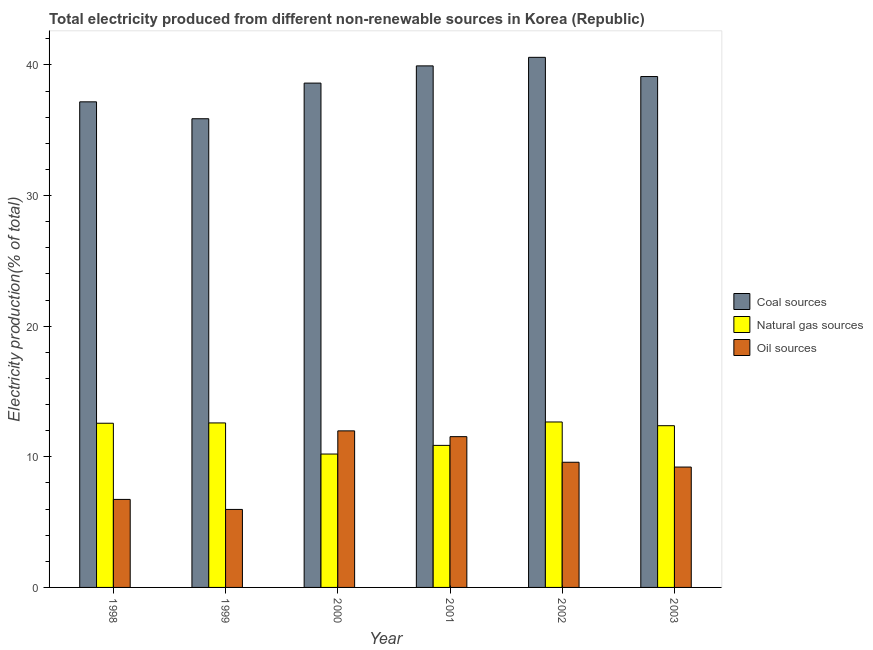How many different coloured bars are there?
Provide a succinct answer. 3. Are the number of bars per tick equal to the number of legend labels?
Provide a short and direct response. Yes. Are the number of bars on each tick of the X-axis equal?
Ensure brevity in your answer.  Yes. How many bars are there on the 2nd tick from the right?
Keep it short and to the point. 3. What is the label of the 5th group of bars from the left?
Your response must be concise. 2002. In how many cases, is the number of bars for a given year not equal to the number of legend labels?
Provide a succinct answer. 0. What is the percentage of electricity produced by coal in 2002?
Ensure brevity in your answer.  40.58. Across all years, what is the maximum percentage of electricity produced by coal?
Your answer should be very brief. 40.58. Across all years, what is the minimum percentage of electricity produced by natural gas?
Provide a succinct answer. 10.21. In which year was the percentage of electricity produced by natural gas minimum?
Give a very brief answer. 2000. What is the total percentage of electricity produced by natural gas in the graph?
Ensure brevity in your answer.  71.29. What is the difference between the percentage of electricity produced by oil sources in 1999 and that in 2003?
Offer a very short reply. -3.24. What is the difference between the percentage of electricity produced by coal in 2000 and the percentage of electricity produced by natural gas in 2002?
Ensure brevity in your answer.  -1.97. What is the average percentage of electricity produced by coal per year?
Your response must be concise. 38.55. In the year 2000, what is the difference between the percentage of electricity produced by coal and percentage of electricity produced by natural gas?
Your response must be concise. 0. In how many years, is the percentage of electricity produced by oil sources greater than 10 %?
Keep it short and to the point. 2. What is the ratio of the percentage of electricity produced by coal in 2000 to that in 2002?
Ensure brevity in your answer.  0.95. What is the difference between the highest and the second highest percentage of electricity produced by natural gas?
Provide a succinct answer. 0.07. What is the difference between the highest and the lowest percentage of electricity produced by coal?
Your answer should be very brief. 4.7. In how many years, is the percentage of electricity produced by coal greater than the average percentage of electricity produced by coal taken over all years?
Your response must be concise. 4. Is the sum of the percentage of electricity produced by coal in 2002 and 2003 greater than the maximum percentage of electricity produced by oil sources across all years?
Keep it short and to the point. Yes. What does the 3rd bar from the left in 1998 represents?
Keep it short and to the point. Oil sources. What does the 1st bar from the right in 2003 represents?
Your answer should be compact. Oil sources. Is it the case that in every year, the sum of the percentage of electricity produced by coal and percentage of electricity produced by natural gas is greater than the percentage of electricity produced by oil sources?
Offer a terse response. Yes. How many bars are there?
Your response must be concise. 18. How many years are there in the graph?
Your response must be concise. 6. What is the difference between two consecutive major ticks on the Y-axis?
Give a very brief answer. 10. Does the graph contain any zero values?
Your answer should be compact. No. Where does the legend appear in the graph?
Your answer should be very brief. Center right. How are the legend labels stacked?
Offer a very short reply. Vertical. What is the title of the graph?
Your response must be concise. Total electricity produced from different non-renewable sources in Korea (Republic). Does "Poland" appear as one of the legend labels in the graph?
Ensure brevity in your answer.  No. What is the label or title of the X-axis?
Give a very brief answer. Year. What is the Electricity production(% of total) in Coal sources in 1998?
Make the answer very short. 37.17. What is the Electricity production(% of total) of Natural gas sources in 1998?
Offer a terse response. 12.57. What is the Electricity production(% of total) of Oil sources in 1998?
Offer a very short reply. 6.74. What is the Electricity production(% of total) in Coal sources in 1999?
Make the answer very short. 35.88. What is the Electricity production(% of total) in Natural gas sources in 1999?
Give a very brief answer. 12.59. What is the Electricity production(% of total) of Oil sources in 1999?
Offer a very short reply. 5.97. What is the Electricity production(% of total) of Coal sources in 2000?
Your answer should be very brief. 38.61. What is the Electricity production(% of total) in Natural gas sources in 2000?
Your answer should be compact. 10.21. What is the Electricity production(% of total) of Oil sources in 2000?
Provide a succinct answer. 11.99. What is the Electricity production(% of total) in Coal sources in 2001?
Your answer should be compact. 39.93. What is the Electricity production(% of total) in Natural gas sources in 2001?
Your response must be concise. 10.87. What is the Electricity production(% of total) of Oil sources in 2001?
Keep it short and to the point. 11.54. What is the Electricity production(% of total) in Coal sources in 2002?
Keep it short and to the point. 40.58. What is the Electricity production(% of total) of Natural gas sources in 2002?
Give a very brief answer. 12.67. What is the Electricity production(% of total) of Oil sources in 2002?
Your answer should be very brief. 9.58. What is the Electricity production(% of total) of Coal sources in 2003?
Make the answer very short. 39.11. What is the Electricity production(% of total) in Natural gas sources in 2003?
Give a very brief answer. 12.38. What is the Electricity production(% of total) of Oil sources in 2003?
Give a very brief answer. 9.21. Across all years, what is the maximum Electricity production(% of total) in Coal sources?
Your answer should be compact. 40.58. Across all years, what is the maximum Electricity production(% of total) of Natural gas sources?
Your answer should be compact. 12.67. Across all years, what is the maximum Electricity production(% of total) in Oil sources?
Offer a terse response. 11.99. Across all years, what is the minimum Electricity production(% of total) in Coal sources?
Offer a terse response. 35.88. Across all years, what is the minimum Electricity production(% of total) of Natural gas sources?
Your response must be concise. 10.21. Across all years, what is the minimum Electricity production(% of total) of Oil sources?
Keep it short and to the point. 5.97. What is the total Electricity production(% of total) of Coal sources in the graph?
Give a very brief answer. 231.28. What is the total Electricity production(% of total) in Natural gas sources in the graph?
Your answer should be compact. 71.29. What is the total Electricity production(% of total) in Oil sources in the graph?
Provide a succinct answer. 55.03. What is the difference between the Electricity production(% of total) of Coal sources in 1998 and that in 1999?
Keep it short and to the point. 1.29. What is the difference between the Electricity production(% of total) of Natural gas sources in 1998 and that in 1999?
Your response must be concise. -0.02. What is the difference between the Electricity production(% of total) in Oil sources in 1998 and that in 1999?
Provide a succinct answer. 0.77. What is the difference between the Electricity production(% of total) of Coal sources in 1998 and that in 2000?
Provide a short and direct response. -1.43. What is the difference between the Electricity production(% of total) in Natural gas sources in 1998 and that in 2000?
Your answer should be compact. 2.36. What is the difference between the Electricity production(% of total) of Oil sources in 1998 and that in 2000?
Offer a very short reply. -5.25. What is the difference between the Electricity production(% of total) in Coal sources in 1998 and that in 2001?
Give a very brief answer. -2.75. What is the difference between the Electricity production(% of total) of Natural gas sources in 1998 and that in 2001?
Ensure brevity in your answer.  1.69. What is the difference between the Electricity production(% of total) of Oil sources in 1998 and that in 2001?
Your answer should be very brief. -4.81. What is the difference between the Electricity production(% of total) of Coal sources in 1998 and that in 2002?
Keep it short and to the point. -3.41. What is the difference between the Electricity production(% of total) of Natural gas sources in 1998 and that in 2002?
Ensure brevity in your answer.  -0.1. What is the difference between the Electricity production(% of total) of Oil sources in 1998 and that in 2002?
Keep it short and to the point. -2.85. What is the difference between the Electricity production(% of total) of Coal sources in 1998 and that in 2003?
Ensure brevity in your answer.  -1.94. What is the difference between the Electricity production(% of total) in Natural gas sources in 1998 and that in 2003?
Provide a short and direct response. 0.19. What is the difference between the Electricity production(% of total) in Oil sources in 1998 and that in 2003?
Your response must be concise. -2.48. What is the difference between the Electricity production(% of total) in Coal sources in 1999 and that in 2000?
Keep it short and to the point. -2.73. What is the difference between the Electricity production(% of total) of Natural gas sources in 1999 and that in 2000?
Your answer should be compact. 2.38. What is the difference between the Electricity production(% of total) of Oil sources in 1999 and that in 2000?
Provide a short and direct response. -6.01. What is the difference between the Electricity production(% of total) in Coal sources in 1999 and that in 2001?
Your answer should be very brief. -4.05. What is the difference between the Electricity production(% of total) of Natural gas sources in 1999 and that in 2001?
Keep it short and to the point. 1.72. What is the difference between the Electricity production(% of total) in Oil sources in 1999 and that in 2001?
Provide a short and direct response. -5.57. What is the difference between the Electricity production(% of total) in Coal sources in 1999 and that in 2002?
Give a very brief answer. -4.7. What is the difference between the Electricity production(% of total) in Natural gas sources in 1999 and that in 2002?
Your response must be concise. -0.07. What is the difference between the Electricity production(% of total) in Oil sources in 1999 and that in 2002?
Offer a very short reply. -3.61. What is the difference between the Electricity production(% of total) of Coal sources in 1999 and that in 2003?
Make the answer very short. -3.23. What is the difference between the Electricity production(% of total) of Natural gas sources in 1999 and that in 2003?
Your answer should be very brief. 0.21. What is the difference between the Electricity production(% of total) of Oil sources in 1999 and that in 2003?
Provide a short and direct response. -3.24. What is the difference between the Electricity production(% of total) of Coal sources in 2000 and that in 2001?
Ensure brevity in your answer.  -1.32. What is the difference between the Electricity production(% of total) of Natural gas sources in 2000 and that in 2001?
Ensure brevity in your answer.  -0.66. What is the difference between the Electricity production(% of total) of Oil sources in 2000 and that in 2001?
Your response must be concise. 0.44. What is the difference between the Electricity production(% of total) of Coal sources in 2000 and that in 2002?
Provide a short and direct response. -1.97. What is the difference between the Electricity production(% of total) in Natural gas sources in 2000 and that in 2002?
Provide a succinct answer. -2.46. What is the difference between the Electricity production(% of total) in Oil sources in 2000 and that in 2002?
Provide a succinct answer. 2.4. What is the difference between the Electricity production(% of total) of Coal sources in 2000 and that in 2003?
Keep it short and to the point. -0.5. What is the difference between the Electricity production(% of total) of Natural gas sources in 2000 and that in 2003?
Provide a succinct answer. -2.17. What is the difference between the Electricity production(% of total) in Oil sources in 2000 and that in 2003?
Make the answer very short. 2.77. What is the difference between the Electricity production(% of total) of Coal sources in 2001 and that in 2002?
Offer a terse response. -0.65. What is the difference between the Electricity production(% of total) in Natural gas sources in 2001 and that in 2002?
Give a very brief answer. -1.79. What is the difference between the Electricity production(% of total) of Oil sources in 2001 and that in 2002?
Make the answer very short. 1.96. What is the difference between the Electricity production(% of total) of Coal sources in 2001 and that in 2003?
Your answer should be compact. 0.82. What is the difference between the Electricity production(% of total) in Natural gas sources in 2001 and that in 2003?
Your answer should be very brief. -1.51. What is the difference between the Electricity production(% of total) in Oil sources in 2001 and that in 2003?
Your response must be concise. 2.33. What is the difference between the Electricity production(% of total) in Coal sources in 2002 and that in 2003?
Your answer should be compact. 1.47. What is the difference between the Electricity production(% of total) of Natural gas sources in 2002 and that in 2003?
Make the answer very short. 0.28. What is the difference between the Electricity production(% of total) of Oil sources in 2002 and that in 2003?
Provide a succinct answer. 0.37. What is the difference between the Electricity production(% of total) of Coal sources in 1998 and the Electricity production(% of total) of Natural gas sources in 1999?
Offer a very short reply. 24.58. What is the difference between the Electricity production(% of total) in Coal sources in 1998 and the Electricity production(% of total) in Oil sources in 1999?
Provide a short and direct response. 31.2. What is the difference between the Electricity production(% of total) of Natural gas sources in 1998 and the Electricity production(% of total) of Oil sources in 1999?
Offer a terse response. 6.6. What is the difference between the Electricity production(% of total) in Coal sources in 1998 and the Electricity production(% of total) in Natural gas sources in 2000?
Offer a terse response. 26.96. What is the difference between the Electricity production(% of total) of Coal sources in 1998 and the Electricity production(% of total) of Oil sources in 2000?
Your answer should be compact. 25.19. What is the difference between the Electricity production(% of total) of Natural gas sources in 1998 and the Electricity production(% of total) of Oil sources in 2000?
Offer a terse response. 0.58. What is the difference between the Electricity production(% of total) of Coal sources in 1998 and the Electricity production(% of total) of Natural gas sources in 2001?
Provide a short and direct response. 26.3. What is the difference between the Electricity production(% of total) in Coal sources in 1998 and the Electricity production(% of total) in Oil sources in 2001?
Your answer should be compact. 25.63. What is the difference between the Electricity production(% of total) of Natural gas sources in 1998 and the Electricity production(% of total) of Oil sources in 2001?
Your answer should be very brief. 1.03. What is the difference between the Electricity production(% of total) of Coal sources in 1998 and the Electricity production(% of total) of Natural gas sources in 2002?
Ensure brevity in your answer.  24.51. What is the difference between the Electricity production(% of total) in Coal sources in 1998 and the Electricity production(% of total) in Oil sources in 2002?
Ensure brevity in your answer.  27.59. What is the difference between the Electricity production(% of total) in Natural gas sources in 1998 and the Electricity production(% of total) in Oil sources in 2002?
Provide a short and direct response. 2.99. What is the difference between the Electricity production(% of total) in Coal sources in 1998 and the Electricity production(% of total) in Natural gas sources in 2003?
Your response must be concise. 24.79. What is the difference between the Electricity production(% of total) of Coal sources in 1998 and the Electricity production(% of total) of Oil sources in 2003?
Your answer should be compact. 27.96. What is the difference between the Electricity production(% of total) of Natural gas sources in 1998 and the Electricity production(% of total) of Oil sources in 2003?
Ensure brevity in your answer.  3.35. What is the difference between the Electricity production(% of total) of Coal sources in 1999 and the Electricity production(% of total) of Natural gas sources in 2000?
Offer a terse response. 25.67. What is the difference between the Electricity production(% of total) of Coal sources in 1999 and the Electricity production(% of total) of Oil sources in 2000?
Your answer should be compact. 23.89. What is the difference between the Electricity production(% of total) in Natural gas sources in 1999 and the Electricity production(% of total) in Oil sources in 2000?
Offer a terse response. 0.61. What is the difference between the Electricity production(% of total) in Coal sources in 1999 and the Electricity production(% of total) in Natural gas sources in 2001?
Provide a short and direct response. 25.01. What is the difference between the Electricity production(% of total) in Coal sources in 1999 and the Electricity production(% of total) in Oil sources in 2001?
Your answer should be very brief. 24.34. What is the difference between the Electricity production(% of total) of Natural gas sources in 1999 and the Electricity production(% of total) of Oil sources in 2001?
Ensure brevity in your answer.  1.05. What is the difference between the Electricity production(% of total) of Coal sources in 1999 and the Electricity production(% of total) of Natural gas sources in 2002?
Ensure brevity in your answer.  23.21. What is the difference between the Electricity production(% of total) in Coal sources in 1999 and the Electricity production(% of total) in Oil sources in 2002?
Provide a short and direct response. 26.3. What is the difference between the Electricity production(% of total) in Natural gas sources in 1999 and the Electricity production(% of total) in Oil sources in 2002?
Your answer should be compact. 3.01. What is the difference between the Electricity production(% of total) of Coal sources in 1999 and the Electricity production(% of total) of Natural gas sources in 2003?
Offer a terse response. 23.5. What is the difference between the Electricity production(% of total) in Coal sources in 1999 and the Electricity production(% of total) in Oil sources in 2003?
Make the answer very short. 26.67. What is the difference between the Electricity production(% of total) of Natural gas sources in 1999 and the Electricity production(% of total) of Oil sources in 2003?
Your response must be concise. 3.38. What is the difference between the Electricity production(% of total) in Coal sources in 2000 and the Electricity production(% of total) in Natural gas sources in 2001?
Offer a terse response. 27.73. What is the difference between the Electricity production(% of total) of Coal sources in 2000 and the Electricity production(% of total) of Oil sources in 2001?
Keep it short and to the point. 27.07. What is the difference between the Electricity production(% of total) in Natural gas sources in 2000 and the Electricity production(% of total) in Oil sources in 2001?
Your response must be concise. -1.33. What is the difference between the Electricity production(% of total) of Coal sources in 2000 and the Electricity production(% of total) of Natural gas sources in 2002?
Ensure brevity in your answer.  25.94. What is the difference between the Electricity production(% of total) of Coal sources in 2000 and the Electricity production(% of total) of Oil sources in 2002?
Ensure brevity in your answer.  29.03. What is the difference between the Electricity production(% of total) in Natural gas sources in 2000 and the Electricity production(% of total) in Oil sources in 2002?
Your response must be concise. 0.63. What is the difference between the Electricity production(% of total) of Coal sources in 2000 and the Electricity production(% of total) of Natural gas sources in 2003?
Offer a terse response. 26.23. What is the difference between the Electricity production(% of total) in Coal sources in 2000 and the Electricity production(% of total) in Oil sources in 2003?
Your answer should be very brief. 29.39. What is the difference between the Electricity production(% of total) in Coal sources in 2001 and the Electricity production(% of total) in Natural gas sources in 2002?
Your response must be concise. 27.26. What is the difference between the Electricity production(% of total) in Coal sources in 2001 and the Electricity production(% of total) in Oil sources in 2002?
Provide a short and direct response. 30.34. What is the difference between the Electricity production(% of total) in Natural gas sources in 2001 and the Electricity production(% of total) in Oil sources in 2002?
Your answer should be compact. 1.29. What is the difference between the Electricity production(% of total) of Coal sources in 2001 and the Electricity production(% of total) of Natural gas sources in 2003?
Keep it short and to the point. 27.54. What is the difference between the Electricity production(% of total) of Coal sources in 2001 and the Electricity production(% of total) of Oil sources in 2003?
Provide a short and direct response. 30.71. What is the difference between the Electricity production(% of total) in Natural gas sources in 2001 and the Electricity production(% of total) in Oil sources in 2003?
Offer a very short reply. 1.66. What is the difference between the Electricity production(% of total) in Coal sources in 2002 and the Electricity production(% of total) in Natural gas sources in 2003?
Offer a terse response. 28.2. What is the difference between the Electricity production(% of total) in Coal sources in 2002 and the Electricity production(% of total) in Oil sources in 2003?
Offer a terse response. 31.37. What is the difference between the Electricity production(% of total) of Natural gas sources in 2002 and the Electricity production(% of total) of Oil sources in 2003?
Keep it short and to the point. 3.45. What is the average Electricity production(% of total) in Coal sources per year?
Your response must be concise. 38.55. What is the average Electricity production(% of total) in Natural gas sources per year?
Your answer should be compact. 11.88. What is the average Electricity production(% of total) in Oil sources per year?
Offer a very short reply. 9.17. In the year 1998, what is the difference between the Electricity production(% of total) of Coal sources and Electricity production(% of total) of Natural gas sources?
Your response must be concise. 24.61. In the year 1998, what is the difference between the Electricity production(% of total) of Coal sources and Electricity production(% of total) of Oil sources?
Make the answer very short. 30.44. In the year 1998, what is the difference between the Electricity production(% of total) of Natural gas sources and Electricity production(% of total) of Oil sources?
Make the answer very short. 5.83. In the year 1999, what is the difference between the Electricity production(% of total) of Coal sources and Electricity production(% of total) of Natural gas sources?
Your response must be concise. 23.29. In the year 1999, what is the difference between the Electricity production(% of total) of Coal sources and Electricity production(% of total) of Oil sources?
Your response must be concise. 29.91. In the year 1999, what is the difference between the Electricity production(% of total) in Natural gas sources and Electricity production(% of total) in Oil sources?
Offer a very short reply. 6.62. In the year 2000, what is the difference between the Electricity production(% of total) of Coal sources and Electricity production(% of total) of Natural gas sources?
Provide a short and direct response. 28.4. In the year 2000, what is the difference between the Electricity production(% of total) of Coal sources and Electricity production(% of total) of Oil sources?
Offer a very short reply. 26.62. In the year 2000, what is the difference between the Electricity production(% of total) of Natural gas sources and Electricity production(% of total) of Oil sources?
Ensure brevity in your answer.  -1.77. In the year 2001, what is the difference between the Electricity production(% of total) in Coal sources and Electricity production(% of total) in Natural gas sources?
Your answer should be compact. 29.05. In the year 2001, what is the difference between the Electricity production(% of total) of Coal sources and Electricity production(% of total) of Oil sources?
Your answer should be very brief. 28.38. In the year 2001, what is the difference between the Electricity production(% of total) of Natural gas sources and Electricity production(% of total) of Oil sources?
Ensure brevity in your answer.  -0.67. In the year 2002, what is the difference between the Electricity production(% of total) in Coal sources and Electricity production(% of total) in Natural gas sources?
Ensure brevity in your answer.  27.91. In the year 2002, what is the difference between the Electricity production(% of total) in Coal sources and Electricity production(% of total) in Oil sources?
Your response must be concise. 31. In the year 2002, what is the difference between the Electricity production(% of total) in Natural gas sources and Electricity production(% of total) in Oil sources?
Provide a short and direct response. 3.08. In the year 2003, what is the difference between the Electricity production(% of total) in Coal sources and Electricity production(% of total) in Natural gas sources?
Ensure brevity in your answer.  26.73. In the year 2003, what is the difference between the Electricity production(% of total) in Coal sources and Electricity production(% of total) in Oil sources?
Provide a succinct answer. 29.9. In the year 2003, what is the difference between the Electricity production(% of total) of Natural gas sources and Electricity production(% of total) of Oil sources?
Your answer should be compact. 3.17. What is the ratio of the Electricity production(% of total) of Coal sources in 1998 to that in 1999?
Provide a short and direct response. 1.04. What is the ratio of the Electricity production(% of total) of Oil sources in 1998 to that in 1999?
Make the answer very short. 1.13. What is the ratio of the Electricity production(% of total) of Coal sources in 1998 to that in 2000?
Provide a succinct answer. 0.96. What is the ratio of the Electricity production(% of total) of Natural gas sources in 1998 to that in 2000?
Your answer should be very brief. 1.23. What is the ratio of the Electricity production(% of total) in Oil sources in 1998 to that in 2000?
Make the answer very short. 0.56. What is the ratio of the Electricity production(% of total) in Coal sources in 1998 to that in 2001?
Your response must be concise. 0.93. What is the ratio of the Electricity production(% of total) of Natural gas sources in 1998 to that in 2001?
Offer a very short reply. 1.16. What is the ratio of the Electricity production(% of total) in Oil sources in 1998 to that in 2001?
Provide a succinct answer. 0.58. What is the ratio of the Electricity production(% of total) of Coal sources in 1998 to that in 2002?
Ensure brevity in your answer.  0.92. What is the ratio of the Electricity production(% of total) in Natural gas sources in 1998 to that in 2002?
Your answer should be compact. 0.99. What is the ratio of the Electricity production(% of total) of Oil sources in 1998 to that in 2002?
Your answer should be very brief. 0.7. What is the ratio of the Electricity production(% of total) of Coal sources in 1998 to that in 2003?
Give a very brief answer. 0.95. What is the ratio of the Electricity production(% of total) of Natural gas sources in 1998 to that in 2003?
Offer a terse response. 1.02. What is the ratio of the Electricity production(% of total) in Oil sources in 1998 to that in 2003?
Your answer should be compact. 0.73. What is the ratio of the Electricity production(% of total) in Coal sources in 1999 to that in 2000?
Offer a very short reply. 0.93. What is the ratio of the Electricity production(% of total) of Natural gas sources in 1999 to that in 2000?
Provide a succinct answer. 1.23. What is the ratio of the Electricity production(% of total) in Oil sources in 1999 to that in 2000?
Your answer should be compact. 0.5. What is the ratio of the Electricity production(% of total) in Coal sources in 1999 to that in 2001?
Provide a succinct answer. 0.9. What is the ratio of the Electricity production(% of total) of Natural gas sources in 1999 to that in 2001?
Provide a short and direct response. 1.16. What is the ratio of the Electricity production(% of total) in Oil sources in 1999 to that in 2001?
Keep it short and to the point. 0.52. What is the ratio of the Electricity production(% of total) in Coal sources in 1999 to that in 2002?
Ensure brevity in your answer.  0.88. What is the ratio of the Electricity production(% of total) of Oil sources in 1999 to that in 2002?
Offer a very short reply. 0.62. What is the ratio of the Electricity production(% of total) in Coal sources in 1999 to that in 2003?
Your answer should be compact. 0.92. What is the ratio of the Electricity production(% of total) in Natural gas sources in 1999 to that in 2003?
Your answer should be compact. 1.02. What is the ratio of the Electricity production(% of total) of Oil sources in 1999 to that in 2003?
Give a very brief answer. 0.65. What is the ratio of the Electricity production(% of total) of Coal sources in 2000 to that in 2001?
Offer a very short reply. 0.97. What is the ratio of the Electricity production(% of total) in Natural gas sources in 2000 to that in 2001?
Make the answer very short. 0.94. What is the ratio of the Electricity production(% of total) in Oil sources in 2000 to that in 2001?
Give a very brief answer. 1.04. What is the ratio of the Electricity production(% of total) of Coal sources in 2000 to that in 2002?
Make the answer very short. 0.95. What is the ratio of the Electricity production(% of total) in Natural gas sources in 2000 to that in 2002?
Provide a succinct answer. 0.81. What is the ratio of the Electricity production(% of total) in Oil sources in 2000 to that in 2002?
Make the answer very short. 1.25. What is the ratio of the Electricity production(% of total) in Coal sources in 2000 to that in 2003?
Your answer should be very brief. 0.99. What is the ratio of the Electricity production(% of total) in Natural gas sources in 2000 to that in 2003?
Provide a succinct answer. 0.82. What is the ratio of the Electricity production(% of total) in Oil sources in 2000 to that in 2003?
Keep it short and to the point. 1.3. What is the ratio of the Electricity production(% of total) of Coal sources in 2001 to that in 2002?
Ensure brevity in your answer.  0.98. What is the ratio of the Electricity production(% of total) of Natural gas sources in 2001 to that in 2002?
Offer a very short reply. 0.86. What is the ratio of the Electricity production(% of total) of Oil sources in 2001 to that in 2002?
Make the answer very short. 1.2. What is the ratio of the Electricity production(% of total) of Coal sources in 2001 to that in 2003?
Provide a succinct answer. 1.02. What is the ratio of the Electricity production(% of total) in Natural gas sources in 2001 to that in 2003?
Your answer should be compact. 0.88. What is the ratio of the Electricity production(% of total) of Oil sources in 2001 to that in 2003?
Your response must be concise. 1.25. What is the ratio of the Electricity production(% of total) in Coal sources in 2002 to that in 2003?
Offer a terse response. 1.04. What is the ratio of the Electricity production(% of total) of Natural gas sources in 2002 to that in 2003?
Make the answer very short. 1.02. What is the ratio of the Electricity production(% of total) of Oil sources in 2002 to that in 2003?
Your answer should be compact. 1.04. What is the difference between the highest and the second highest Electricity production(% of total) in Coal sources?
Offer a very short reply. 0.65. What is the difference between the highest and the second highest Electricity production(% of total) in Natural gas sources?
Your answer should be compact. 0.07. What is the difference between the highest and the second highest Electricity production(% of total) in Oil sources?
Your response must be concise. 0.44. What is the difference between the highest and the lowest Electricity production(% of total) of Coal sources?
Give a very brief answer. 4.7. What is the difference between the highest and the lowest Electricity production(% of total) of Natural gas sources?
Provide a succinct answer. 2.46. What is the difference between the highest and the lowest Electricity production(% of total) in Oil sources?
Your answer should be very brief. 6.01. 